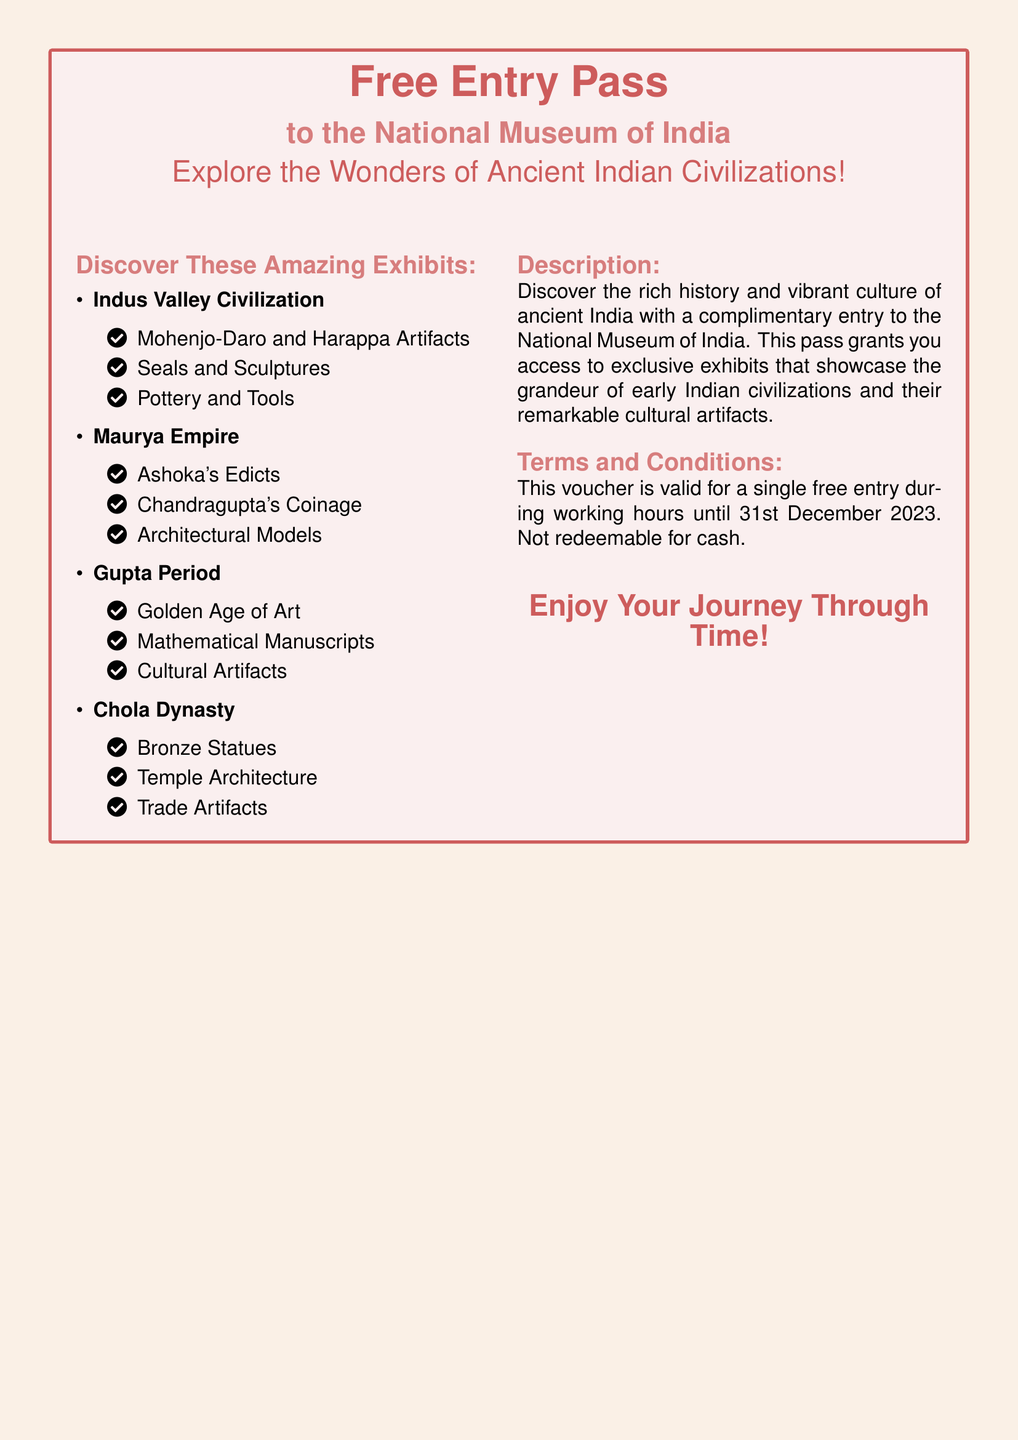What is the title of the gift voucher? The title prominently displayed at the top of the document is "Free Entry Pass."
Answer: Free Entry Pass What museum does the voucher grant entry to? The document specifies the National Museum of India as the location for the free entry.
Answer: National Museum of India Until when is the voucher valid? The expiration date mentioned in the terms and conditions section is 31st December 2023.
Answer: 31st December 2023 What civilization's artifacts are featured from the Gupta Period? The document states that artifacts from the Gupta Period include items from the "Golden Age of Art."
Answer: Golden Age of Art What type of artifacts are highlighted from the Indus Valley Civilization? The document lists "Mohenjo-Daro and Harappa Artifacts" as part of the exhibits for the Indus Valley Civilization.
Answer: Mohenjo-Daro and Harappa Artifacts How many major ancient civilizations are detailed in the document? The document mentions four major ancient civilizations in the exhibits section.
Answer: Four What are the working hours for voucher redemption? The document does not specify the exact working hours for the museum.
Answer: Not specified What does the voucher explicitly state about cash redemption? The terms state that the voucher is "not redeemable for cash."
Answer: Not redeemable for cash What type of document is this? The document is a gift voucher offering free entry to a museum.
Answer: Gift voucher 